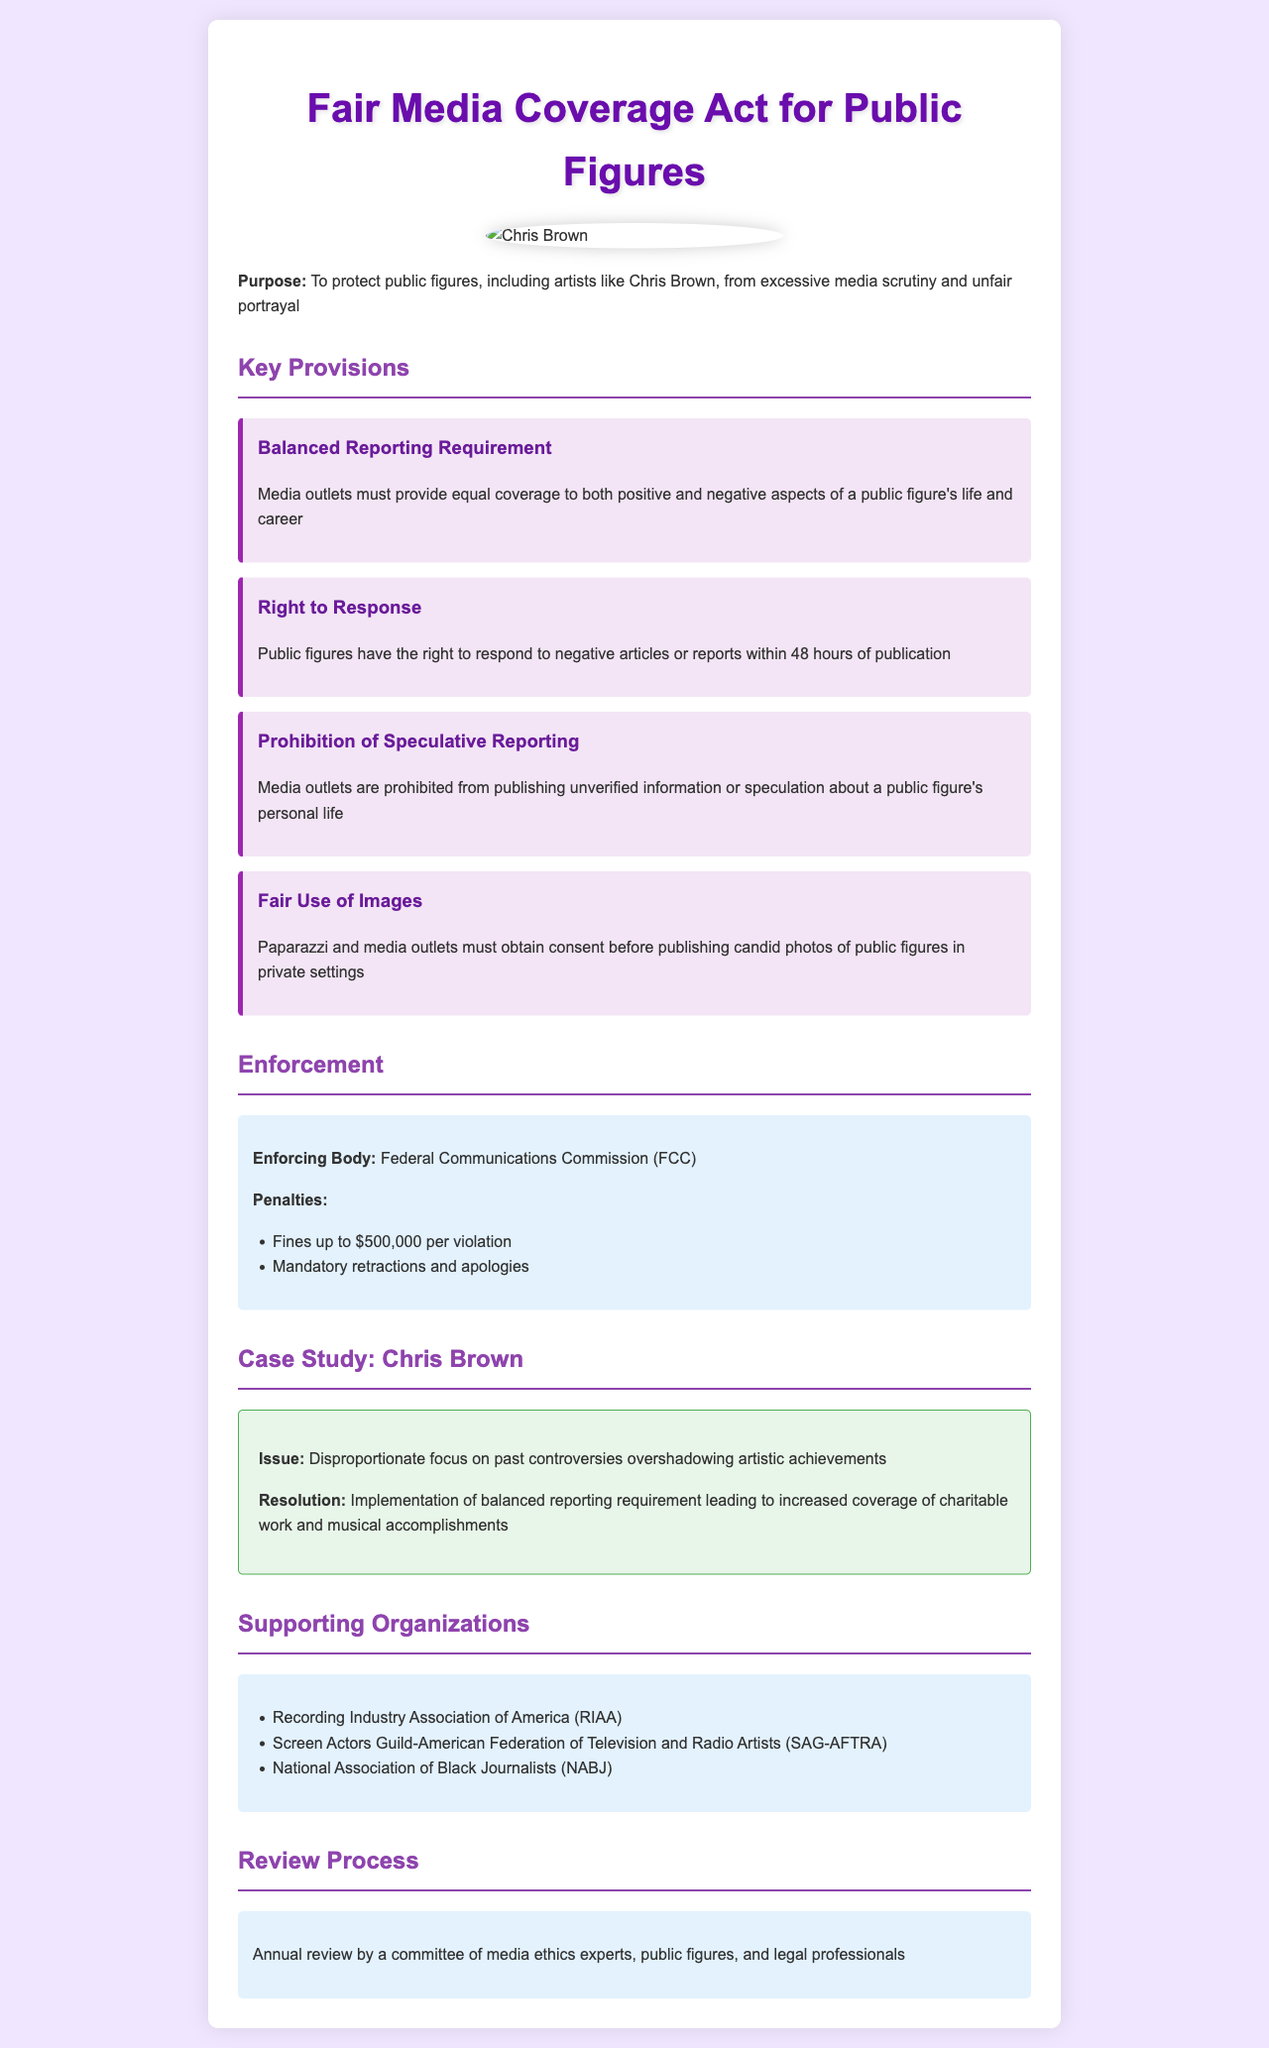What is the title of the document? The title of the document is displayed prominently at the top of the rendered content.
Answer: Fair Media Coverage Act for Public Figures Who enforces the policy? The document indicates the body responsible for enforcing the provisions laid out within it.
Answer: Federal Communications Commission (FCC) What is the penalty for a violation? The penalties are outlined in a section specifically dedicated to enforcement in the document.
Answer: Fines up to $500,000 per violation How long do public figures have to respond to negative articles? The timeframe for public figures to exercise their right to respond is specified in the relevant provision.
Answer: 48 hours What action can be taken against media outlets for violations? The document lists a specific consequence outlined in the enforcement section concerning media outlets that break the rules.
Answer: Mandatory retractions and apologies What does the case study focus on? The focus of the case study, which illustrates a specific real-world application of the policy, is stated clearly in the section.
Answer: Disproportionate focus on past controversies overshadowing artistic achievements Which organization is mentioned as a supporter of the policy? The document contains a list of organizations that support the policy, and one of them is specifically highlighted.
Answer: Recording Industry Association of America (RIAA) What requirement must media outlets follow regarding reporting? One of the key provisions details specific requirements that media outlets must adhere to when reporting on public figures.
Answer: Balanced Reporting Requirement 